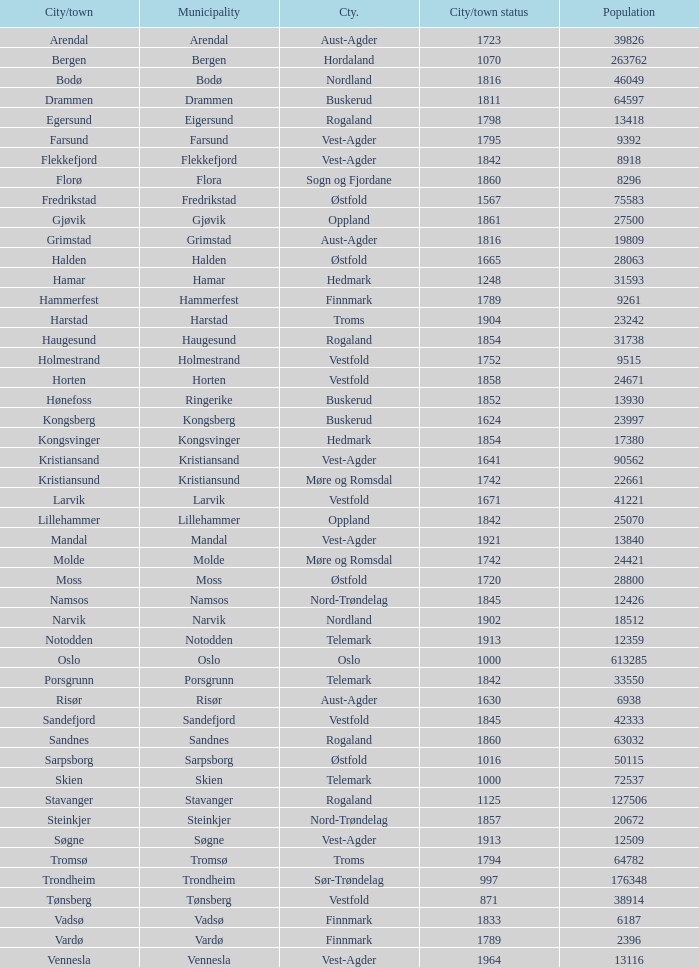Which towns situated in the finnmark county have populations larger than 618 Hammerfest. 